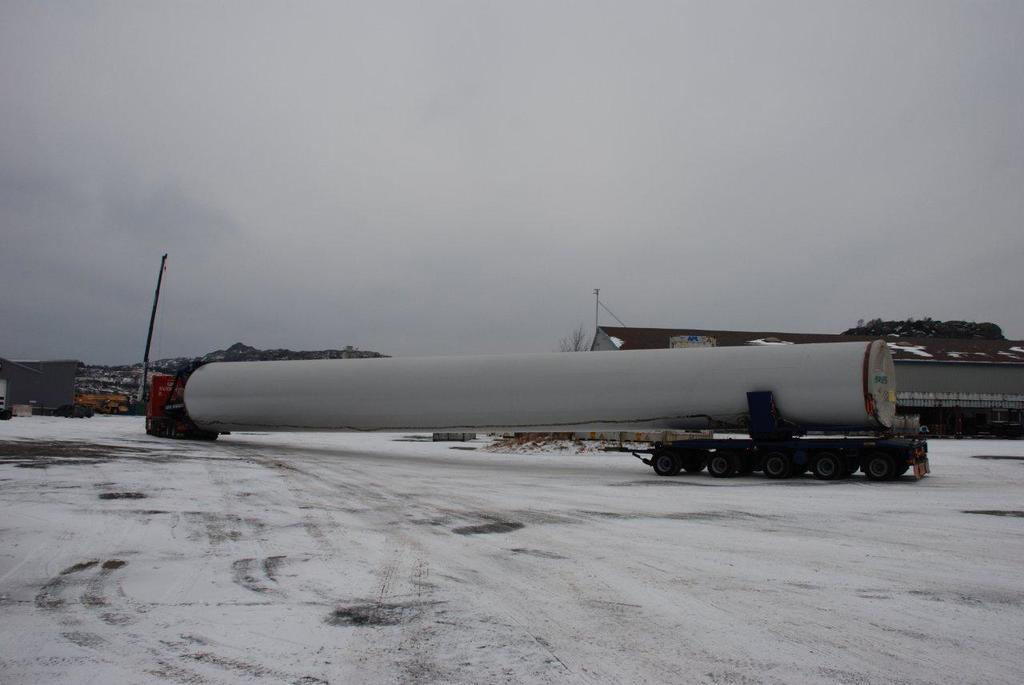What is the main subject in the front of the image? There is a vehicle in the front of the image. What can be seen in the background of the image? There is a building and poles visible in the background of the image. What else is present in the background of the image? Wires are present in the background of the image. What is visible in the sky in the image? There are clouds in the sky, and the sky is visible in the background of the image. Is there a tent set up for a party in the image? There is no tent or party present in the image. Can you see a road in the image? The image does not show a road; it features a vehicle, a building, poles, wires, clouds, and the sky. 